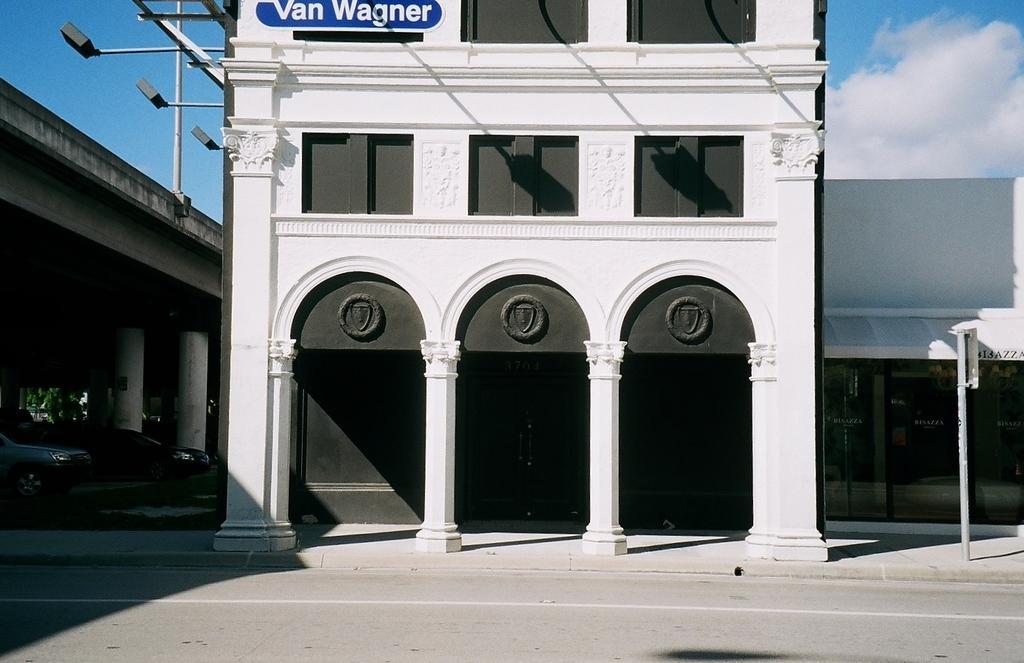In one or two sentences, can you explain what this image depicts? We can see building,pillars, board on pole and cars. In the background we can see sky with clouds. 